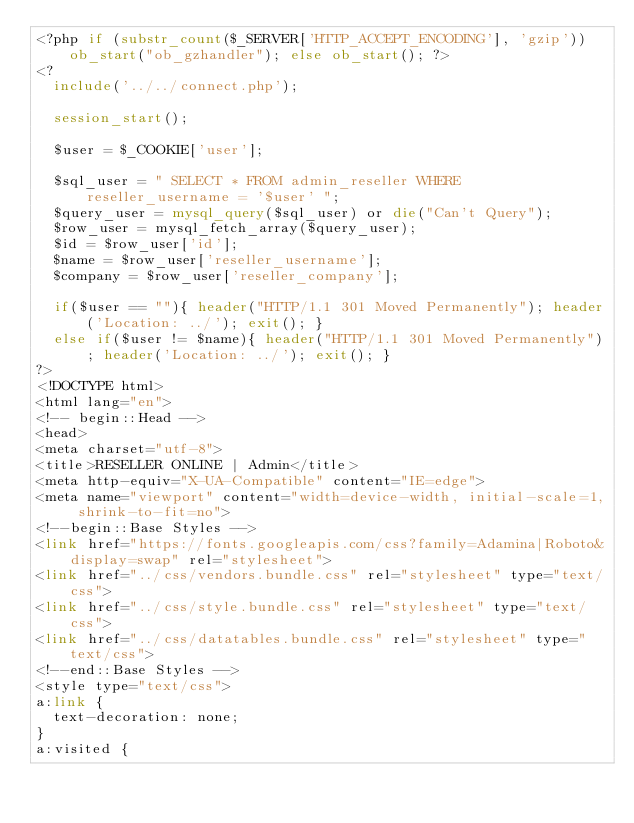Convert code to text. <code><loc_0><loc_0><loc_500><loc_500><_PHP_><?php if (substr_count($_SERVER['HTTP_ACCEPT_ENCODING'], 'gzip')) ob_start("ob_gzhandler"); else ob_start(); ?>
<?	
	include('../../connect.php');
	
	session_start();
	
	$user = $_COOKIE['user'];

	$sql_user =	" SELECT * FROM admin_reseller WHERE reseller_username = '$user' ";
	$query_user = mysql_query($sql_user) or die("Can't Query");
	$row_user = mysql_fetch_array($query_user);
	$id = $row_user['id'];
	$name = $row_user['reseller_username'];
	$company = $row_user['reseller_company'];

	if($user == ""){ header("HTTP/1.1 301 Moved Permanently"); header('Location: ../'); exit(); }
	else if($user != $name){ header("HTTP/1.1 301 Moved Permanently"); header('Location: ../'); exit(); }
?>
<!DOCTYPE html>
<html lang="en">
<!-- begin::Head -->
<head>
<meta charset="utf-8">
<title>RESELLER ONLINE | Admin</title>
<meta http-equiv="X-UA-Compatible" content="IE=edge">
<meta name="viewport" content="width=device-width, initial-scale=1, shrink-to-fit=no">
<!--begin::Base Styles -->
<link href="https://fonts.googleapis.com/css?family=Adamina|Roboto&display=swap" rel="stylesheet">
<link href="../css/vendors.bundle.css" rel="stylesheet" type="text/css">
<link href="../css/style.bundle.css" rel="stylesheet" type="text/css">
<link href="../css/datatables.bundle.css" rel="stylesheet" type="text/css">
<!--end::Base Styles -->
<style type="text/css">
a:link {
	text-decoration: none;
}
a:visited {</code> 